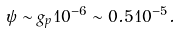Convert formula to latex. <formula><loc_0><loc_0><loc_500><loc_500>\psi \sim g _ { p } 1 0 ^ { - 6 } \sim 0 . 5 1 0 ^ { - 5 } .</formula> 